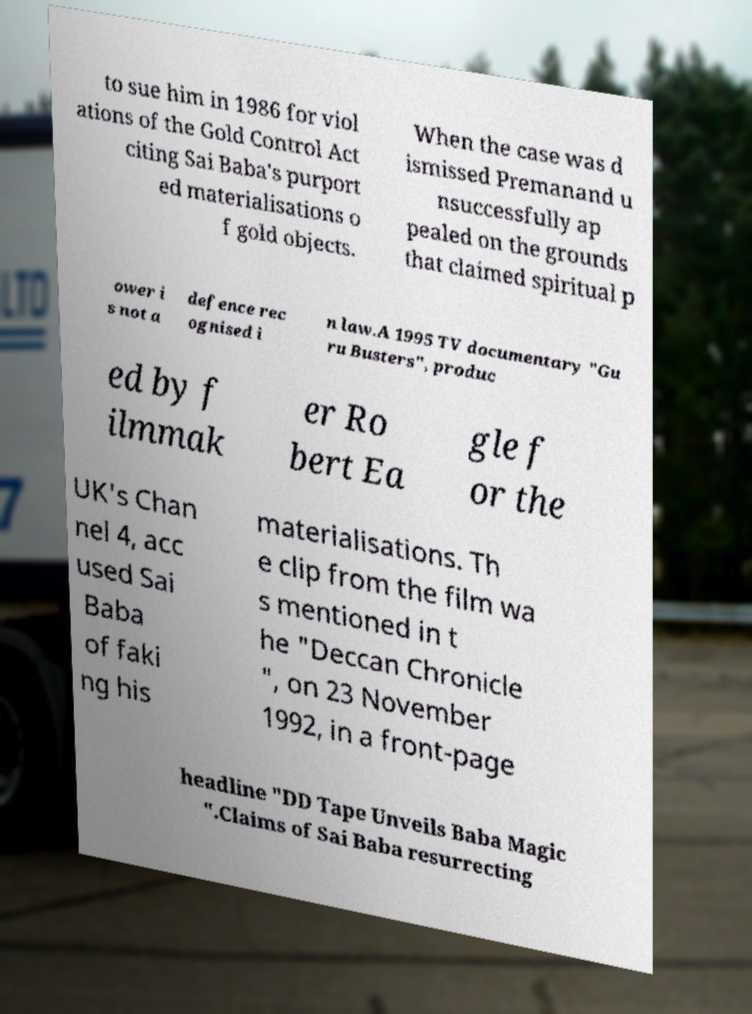Could you assist in decoding the text presented in this image and type it out clearly? to sue him in 1986 for viol ations of the Gold Control Act citing Sai Baba's purport ed materialisations o f gold objects. When the case was d ismissed Premanand u nsuccessfully ap pealed on the grounds that claimed spiritual p ower i s not a defence rec ognised i n law.A 1995 TV documentary "Gu ru Busters", produc ed by f ilmmak er Ro bert Ea gle f or the UK's Chan nel 4, acc used Sai Baba of faki ng his materialisations. Th e clip from the film wa s mentioned in t he "Deccan Chronicle ", on 23 November 1992, in a front-page headline "DD Tape Unveils Baba Magic ".Claims of Sai Baba resurrecting 